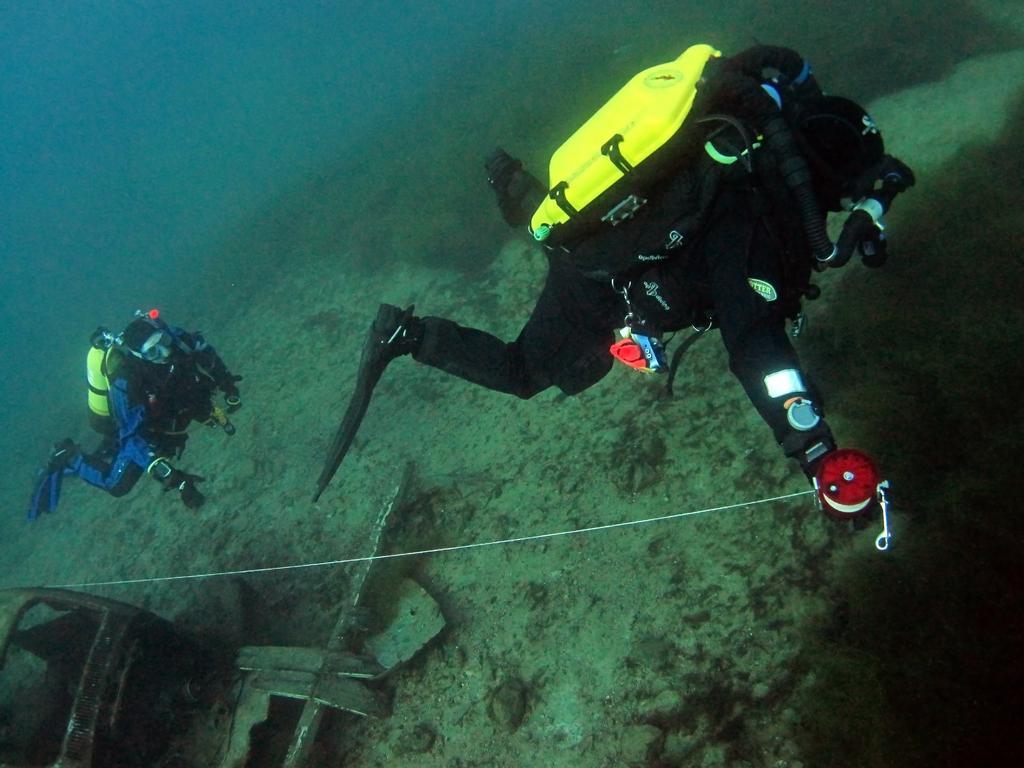Describe this image in one or two sentences. In the image we can see two people swimming, they are wearing a swimming suit and on their back there is an oxygen cylinder. Here we can see an object. 